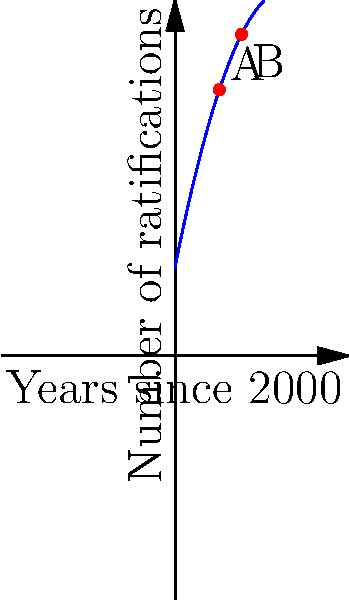The graph shows the cumulative number of ratifications for an international treaty over time. Points A and B represent the number of ratifications at 10 and 15 years after the year 2000, respectively. What is the average rate of change in ratifications per year between points A and B? To find the average rate of change between points A and B, we need to:

1. Determine the coordinates of points A and B:
   A: (10, f(10)) = (10, 20 + 5*10 - 0.1*10^2) = (10, 60)
   B: (15, f(15)) = (15, 20 + 5*15 - 0.1*15^2) = (15, 57.5)

2. Calculate the change in y (number of ratifications):
   Δy = 57.5 - 60 = -2.5

3. Calculate the change in x (years):
   Δx = 15 - 10 = 5

4. Apply the average rate of change formula:
   Average rate of change = Δy / Δx = -2.5 / 5 = -0.5

Therefore, the average rate of change in ratifications per year between points A and B is -0.5 ratifications per year.
Answer: -0.5 ratifications/year 